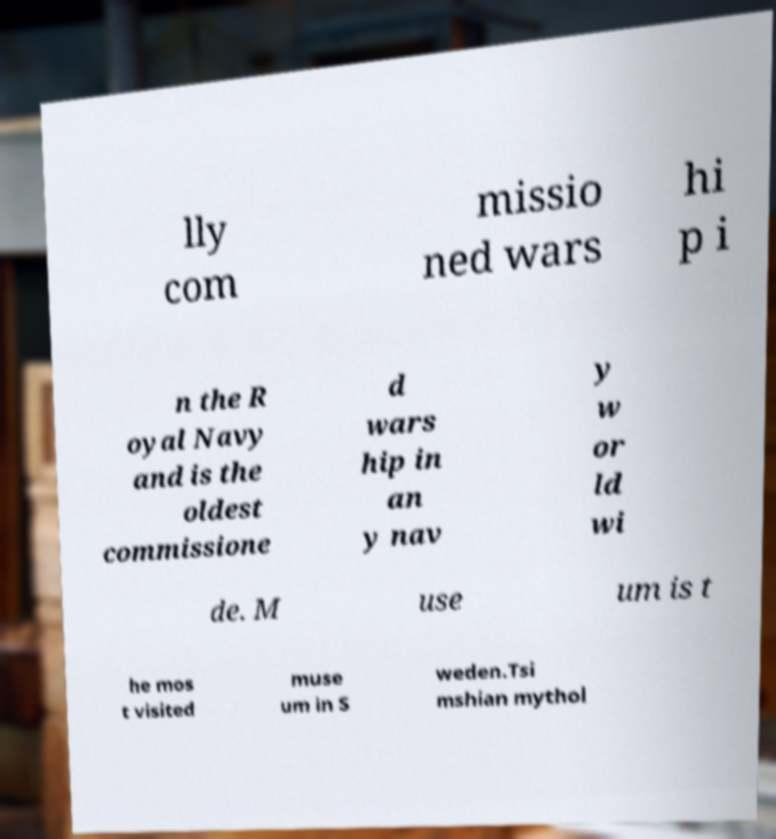What messages or text are displayed in this image? I need them in a readable, typed format. lly com missio ned wars hi p i n the R oyal Navy and is the oldest commissione d wars hip in an y nav y w or ld wi de. M use um is t he mos t visited muse um in S weden.Tsi mshian mythol 